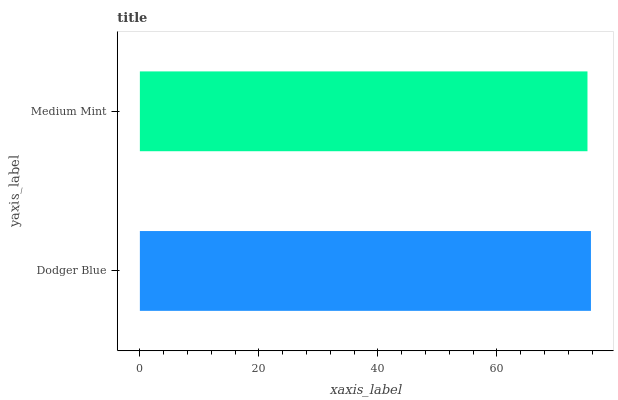Is Medium Mint the minimum?
Answer yes or no. Yes. Is Dodger Blue the maximum?
Answer yes or no. Yes. Is Medium Mint the maximum?
Answer yes or no. No. Is Dodger Blue greater than Medium Mint?
Answer yes or no. Yes. Is Medium Mint less than Dodger Blue?
Answer yes or no. Yes. Is Medium Mint greater than Dodger Blue?
Answer yes or no. No. Is Dodger Blue less than Medium Mint?
Answer yes or no. No. Is Dodger Blue the high median?
Answer yes or no. Yes. Is Medium Mint the low median?
Answer yes or no. Yes. Is Medium Mint the high median?
Answer yes or no. No. Is Dodger Blue the low median?
Answer yes or no. No. 